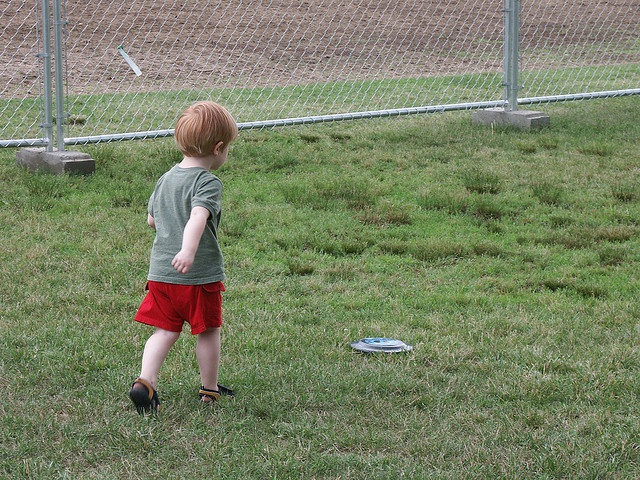Describe the objects in this image and their specific colors. I can see people in gray, darkgray, maroon, and brown tones and frisbee in gray, lavender, darkgray, and lightblue tones in this image. 